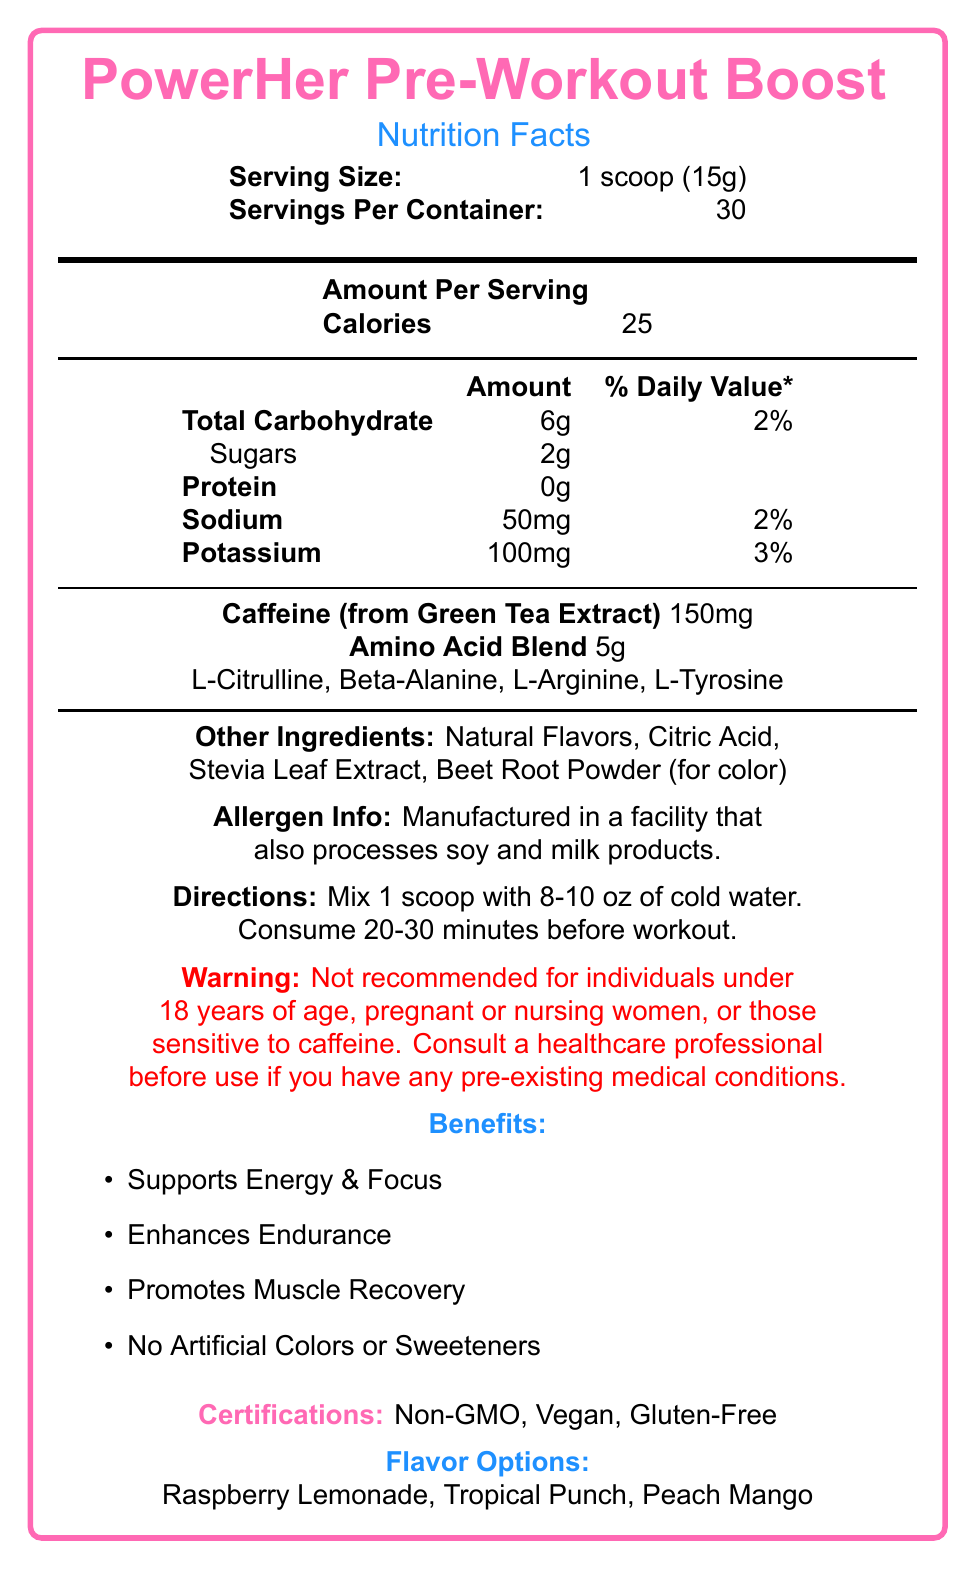what is the serving size? The document lists "Serving Size: 1 scoop (15g)" at the top.
Answer: 1 scoop (15g) how many servings are in each container? The document indicates "Servings Per Container: 30" at the top.
Answer: 30 what is the calorie count per serving? Under the "Amount Per Serving" section, it states "Calories: 25."
Answer: 25 calories how much total carbohydrate is there per serving, and what percentage of the daily value does it represent? The "Total Carbohydrate" entry lists "6g" and "2%" as the amount and daily value percentage, respectively.
Answer: 6g, 2% what is the source of caffeine in this supplement? Under the "Caffeine" section, it specifies "Caffeine (from Green Tea Extract) 150mg."
Answer: Green Tea Extract what are the benefits of this pre-workout supplement? The document lists these benefits under the "Benefits" section.
Answer: Supports Energy & Focus, Enhances Endurance, Promotes Muscle Recovery, No Artificial Colors or Sweeteners which amino acids are included in the Amino Acid Blend? A. L-Citrulline, Beta-Alanine B. L-Arginine, L-Tyrosine C. All of the above The "Amino Acid Blend" section lists L-Citrulline, Beta-Alanine, L-Arginine, and L-Tyrosine as ingredients.
Answer: C. All of the above what flavor options are available for this pre-workout supplement? A. Raspberry Lemonade, Tropical Punch, Chocolate B. Tropical Punch, Peach Mango, Raspberry Lemonade C. Raspberry Lemonade, Peach Mango, Vanilla The document lists the flavor options as "Raspberry Lemonade, Tropical Punch, Peach Mango."
Answer: B. Tropical Punch, Peach Mango, Raspberry Lemonade is this product safe for pregnant women? The warning section specifically states, "Not recommended for individuals under 18 years of age, pregnant or nursing women, or those sensitive to caffeine."
Answer: No summarize the main features and ingredients of the PowerHer Pre-Workout Boost. An explanation stating the document presents detailed information about the serving size, servings per container, nutritional content, ingredients, benefits, and warnings for the PowerHer Pre-Workout Boost.
Answer: The PowerHer Pre-Workout Boost is a pre-workout supplement designed to enhance energy, focus, endurance, and muscle recovery. Each serving of 1 scoop (15g) contains 25 calories, 6g of total carbohydrates, 2g of sugars, 50mg of sodium, 100mg of potassium, 150mg of caffeine from green tea extract, and a 5g amino acid blend which includes L-Citrulline, Beta-Alanine, L-Arginine, and L-Tyrosine. It includes natural flavors, citric acid, stevia leaf extract, and beet root powder for color. It is vegan, non-GMO, gluten-free, and contains no artificial colors or sweeteners. It offers three flavors: Raspberry Lemonade, Tropical Punch, and Peach Mango. what is the daily value percentage of sodium in one serving? The document lists "Sodium 50mg" with a daily value percentage of "2%."
Answer: 2% can I find information on the price of the supplement in the document? The document does not provide any information about the price of the supplement.
Answer: Not enough information 